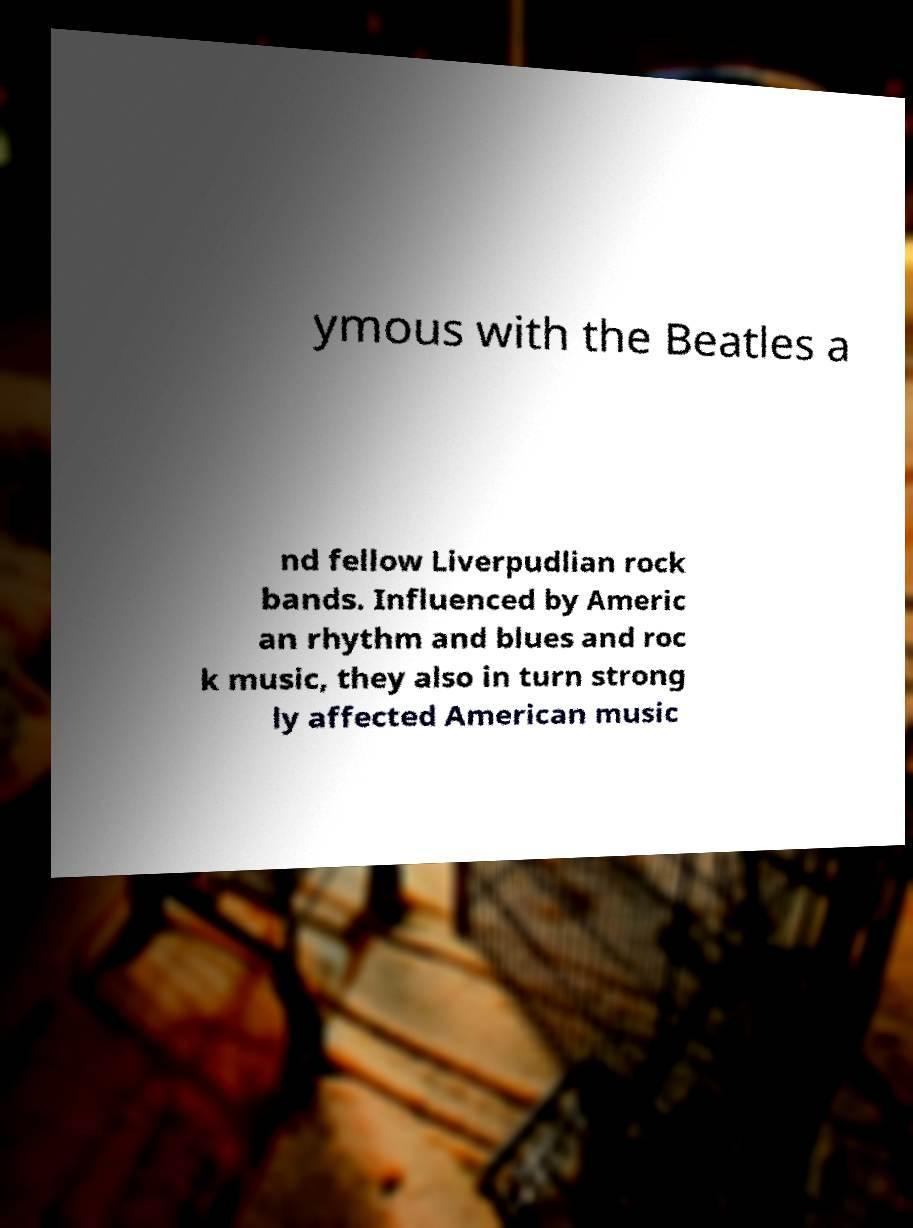What messages or text are displayed in this image? I need them in a readable, typed format. ymous with the Beatles a nd fellow Liverpudlian rock bands. Influenced by Americ an rhythm and blues and roc k music, they also in turn strong ly affected American music 